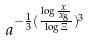Convert formula to latex. <formula><loc_0><loc_0><loc_500><loc_500>a ^ { - \frac { 1 } { 3 } ( \frac { \log \frac { x } { x _ { 8 } } } { \log \Xi } ) ^ { 3 } }</formula> 